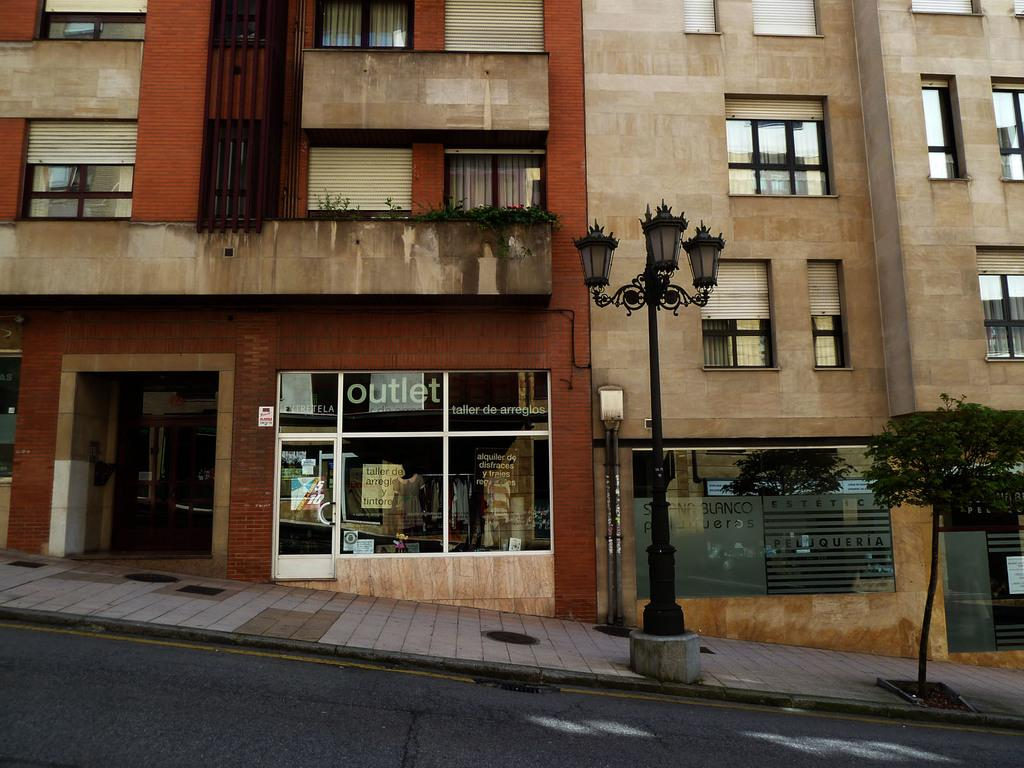What type of path is visible in the image? There is a footpath in the image. What type of structure can be seen in the image? There are buildings with windows in the image. What type of vegetation is present in the image? There is a tree in the image. What type of lighting is present in the image? There are lights in the image. What type of support structure is present in the image? There is a pole in the image. What type of signage is present in the image? There are posters in the image. What type of window coverings are present in the image? There are curtains and shutters in the image. What type of spark can be seen in the image? There is no spark present in the image. What type of zinc object is visible in the image? There is no zinc object present in the image. 